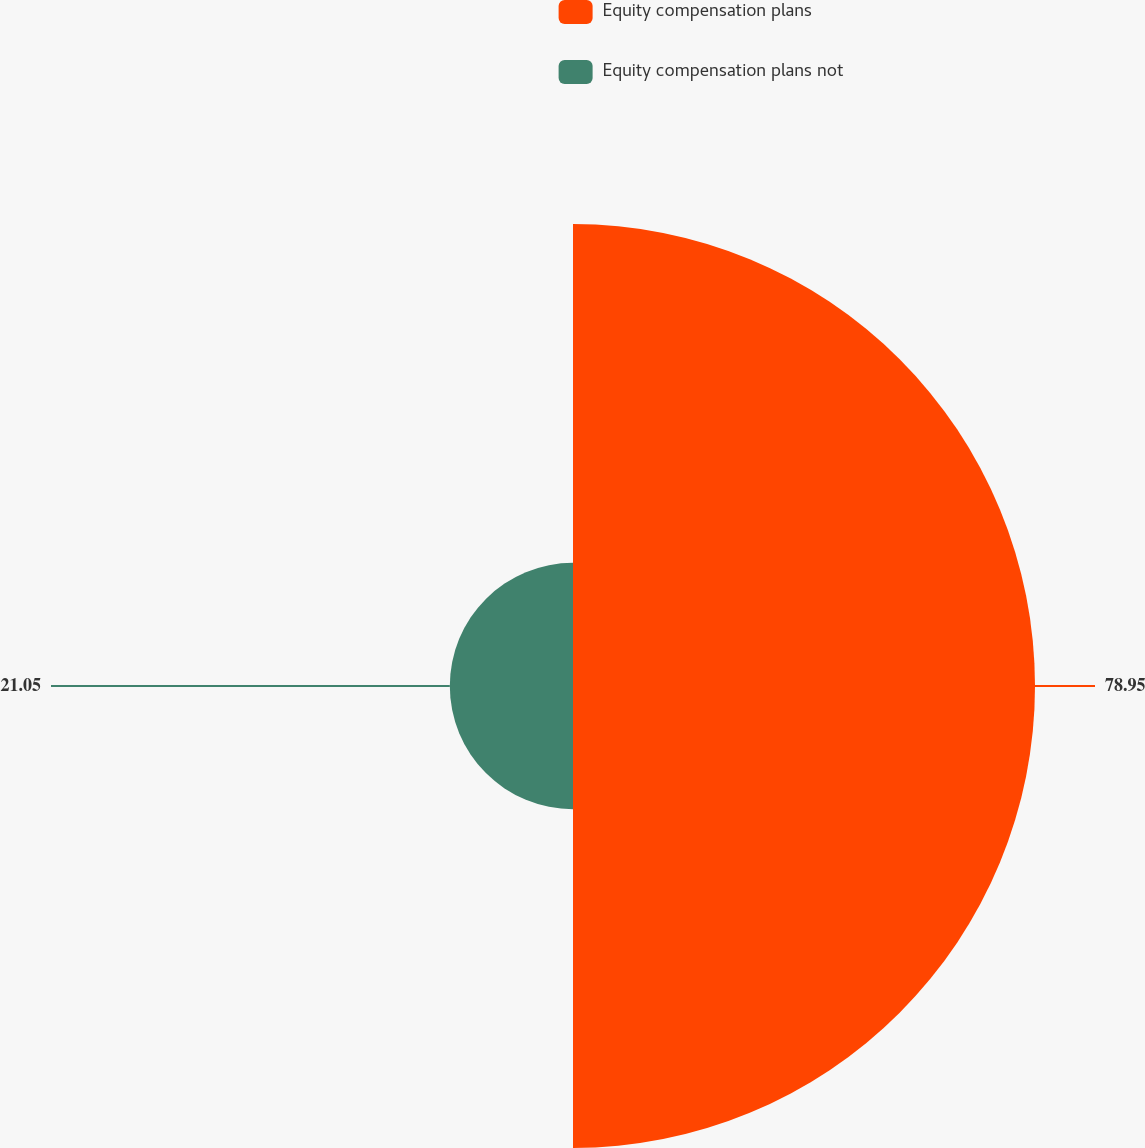<chart> <loc_0><loc_0><loc_500><loc_500><pie_chart><fcel>Equity compensation plans<fcel>Equity compensation plans not<nl><fcel>78.95%<fcel>21.05%<nl></chart> 